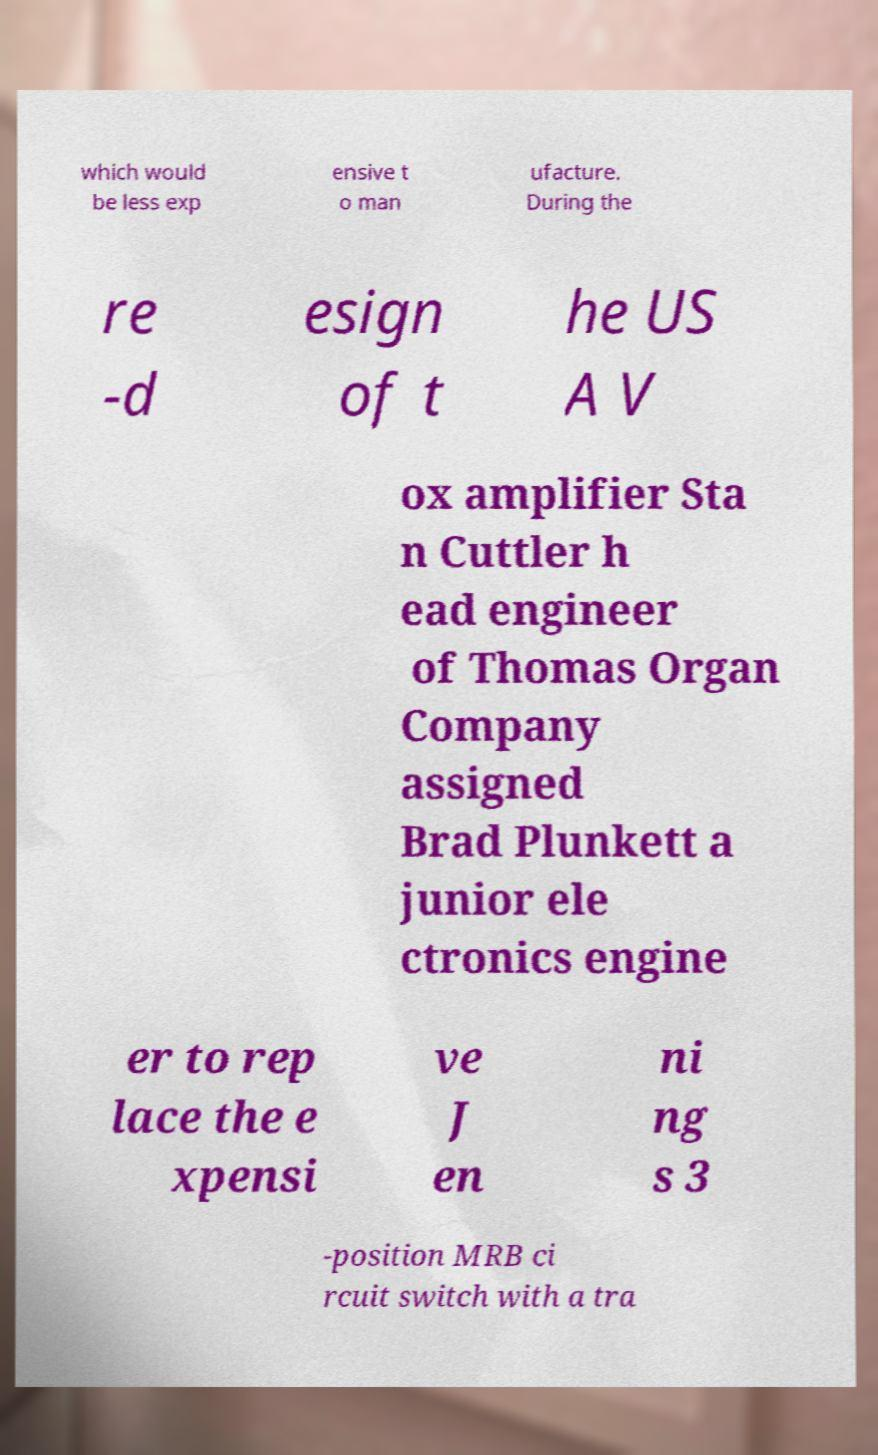I need the written content from this picture converted into text. Can you do that? which would be less exp ensive t o man ufacture. During the re -d esign of t he US A V ox amplifier Sta n Cuttler h ead engineer of Thomas Organ Company assigned Brad Plunkett a junior ele ctronics engine er to rep lace the e xpensi ve J en ni ng s 3 -position MRB ci rcuit switch with a tra 